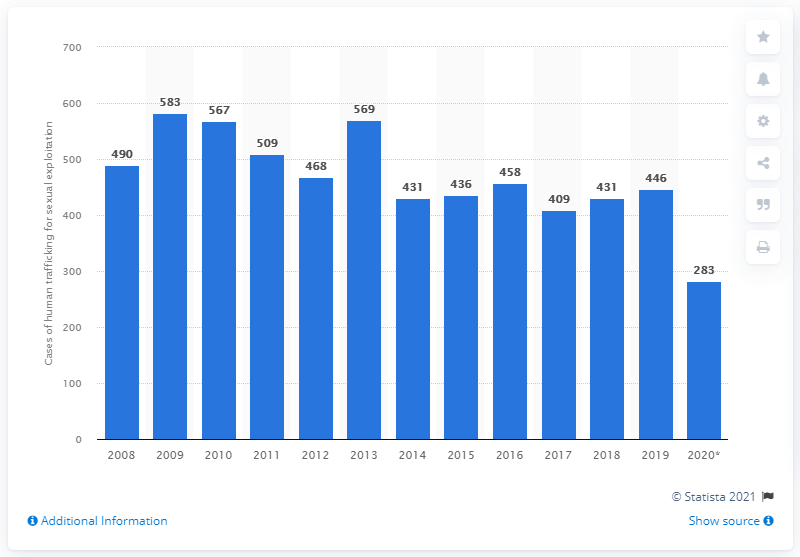Mention a couple of crucial points in this snapshot. In 2020, a total of 283 cases of sexual trafficking were registered. 